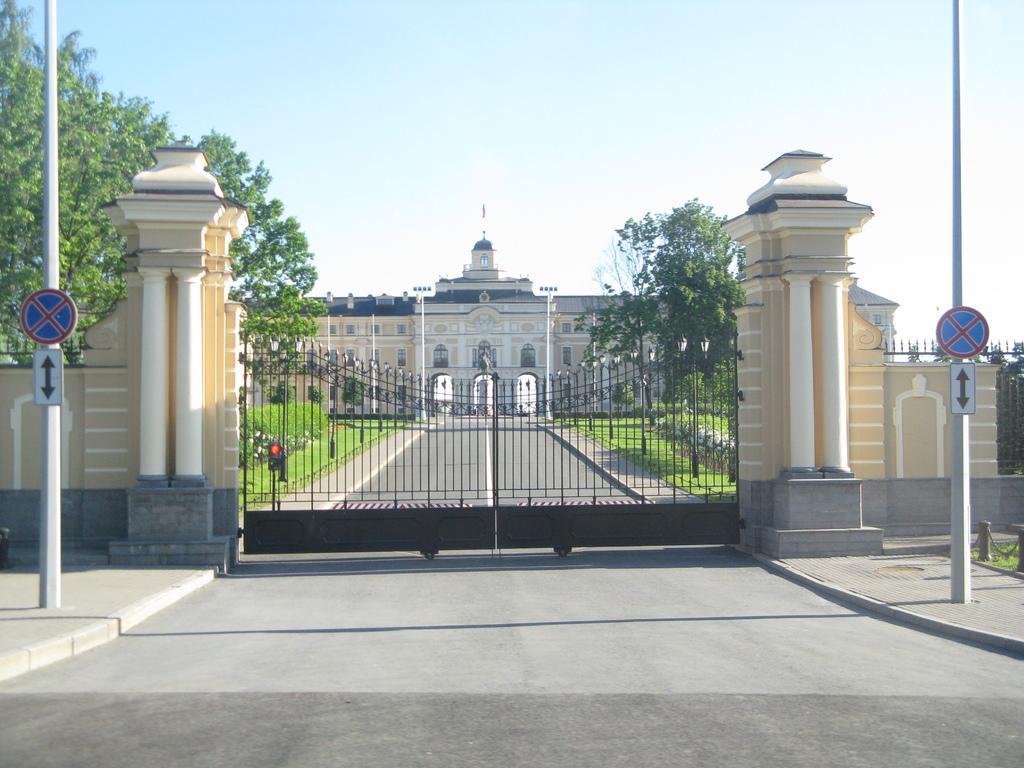Describe this image in one or two sentences. At the bottom of the picture, we see the road. On either side of the picture, we see poles and boards in white and blue color. In the middle of the picture, we see a gate and the pillars. On either side of the gate, we see grass and trees. In the background, we see a palace. At the top of the picture, we see the sky. 